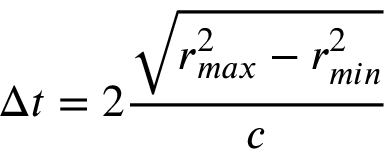Convert formula to latex. <formula><loc_0><loc_0><loc_500><loc_500>\Delta t = 2 \frac { \sqrt { r _ { \max } ^ { 2 } - r _ { \min } ^ { 2 } } } { c }</formula> 